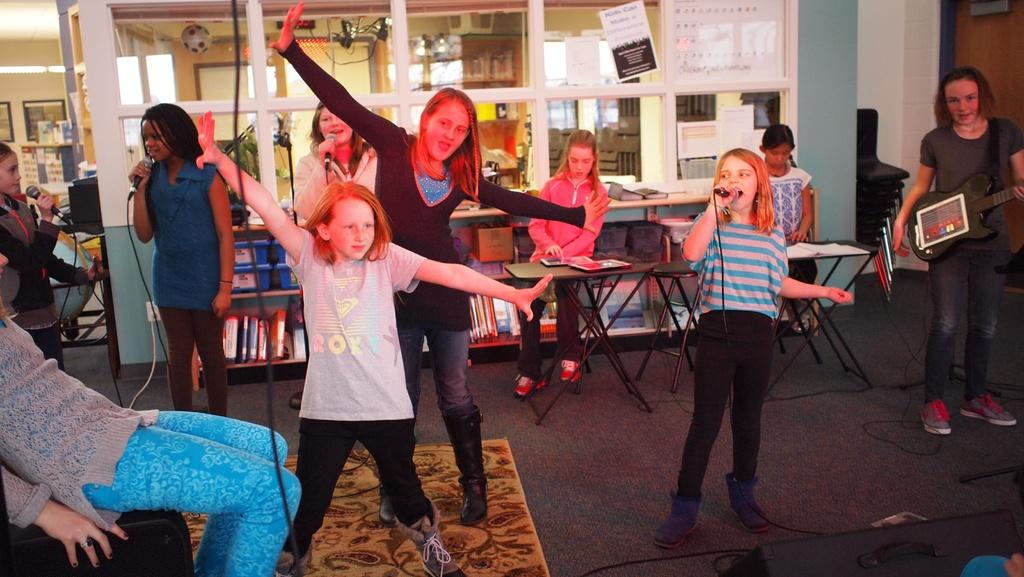What are the people in the image doing? The people in the image are dancing, singing, and playing musical instruments. Can you describe the setting of the image? There are tables and chairs in the background of the image, and there is a carpet on the floor. What type of activities are taking place in the image? People are dancing, singing, and playing musical instruments, which suggests a performance or gathering. What is the smell of the crowd in the image? There is no mention of a crowd in the image, and therefore no smell can be attributed to it. 